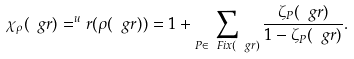<formula> <loc_0><loc_0><loc_500><loc_500>\chi _ { \rho } ( \ g r ) = ^ { u } r ( \rho ( { \ g r } ) ) = 1 + \sum _ { P \in \ F i x ( \ g r ) } \frac { \zeta _ { P } ( \ g r ) } { 1 - \zeta _ { P } ( \ g r ) } .</formula> 